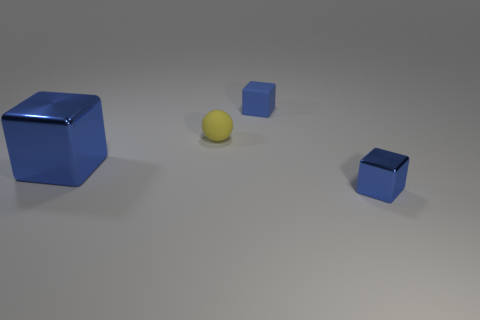Subtract all small shiny cubes. How many cubes are left? 2 Add 4 small yellow rubber spheres. How many objects exist? 8 Subtract 0 yellow cylinders. How many objects are left? 4 Subtract all balls. How many objects are left? 3 Subtract 2 cubes. How many cubes are left? 1 Subtract all brown blocks. Subtract all gray balls. How many blocks are left? 3 Subtract all purple spheres. How many yellow cubes are left? 0 Subtract all yellow rubber objects. Subtract all rubber blocks. How many objects are left? 2 Add 1 small blue things. How many small blue things are left? 3 Add 2 yellow metal balls. How many yellow metal balls exist? 2 